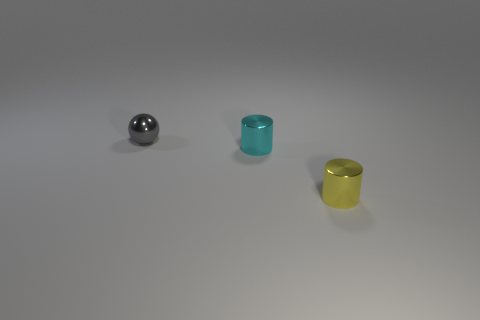Is there anything else that is the same color as the sphere?
Offer a terse response. No. What shape is the small gray metal object to the left of the shiny thing that is on the right side of the cylinder that is left of the yellow object?
Keep it short and to the point. Sphere. Is the number of yellow metal cylinders less than the number of small shiny objects?
Ensure brevity in your answer.  Yes. Are there any yellow shiny cylinders in front of the metal sphere?
Ensure brevity in your answer.  Yes. There is a small object that is both on the left side of the yellow cylinder and on the right side of the tiny gray thing; what is its shape?
Ensure brevity in your answer.  Cylinder. Is there a yellow object of the same shape as the tiny cyan object?
Ensure brevity in your answer.  Yes. There is a cylinder behind the small yellow cylinder; is it the same size as the gray thing behind the tiny yellow metal cylinder?
Ensure brevity in your answer.  Yes. Is the number of yellow cylinders greater than the number of big rubber things?
Ensure brevity in your answer.  Yes. How many yellow cylinders are the same material as the gray object?
Your answer should be compact. 1. Does the gray object have the same shape as the small cyan shiny object?
Give a very brief answer. No. 